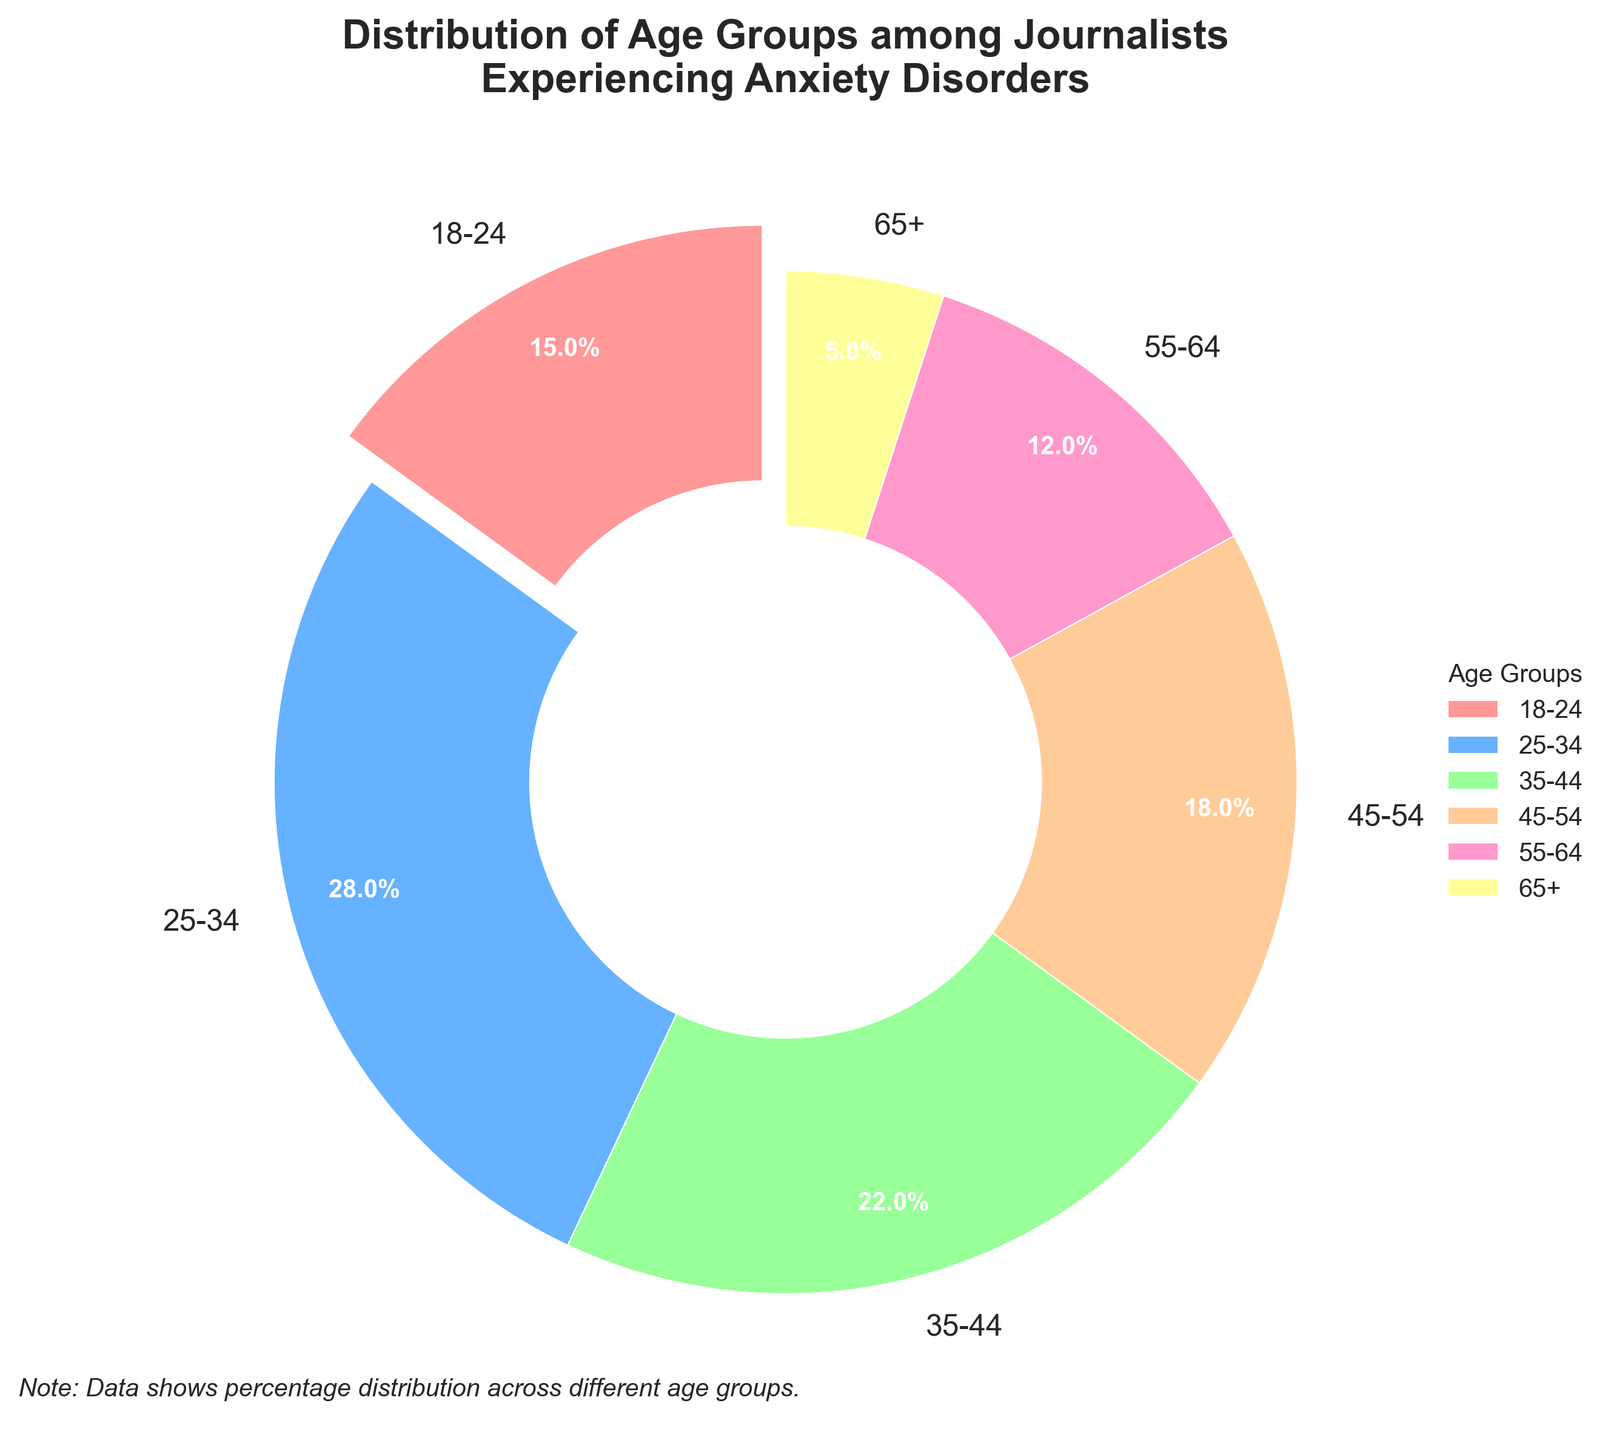Which age group has the highest percentage of journalists experiencing anxiety disorders? The figure shows a pie chart where each segment represents a different age group and their corresponding percentage. The age group with the highest percentage is clearly labeled.
Answer: 25-34 Which age group has the lowest percentage of journalists experiencing anxiety disorders? By observing the pie chart, we can identify the smallest segment, which represents the age group with the lowest percentage. This group is labeled on the chart.
Answer: 65+ What is the combined percentage of journalists aged 18-24 and 35-44 experiencing anxiety disorders? To find the combined percentage, sum the percentages of the 18-24 and 35-44 age groups: 15% (18-24) + 22% (35-44).
Answer: 37% How many percentage points more of journalists aged 25-34 experience anxiety disorders compared to those aged 55-64? Subtract the percentage of the 55-64 age group (12%) from the percentage of the 25-34 age group (28%): 28% - 12%.
Answer: 16% What percentage of journalists experiencing anxiety disorders are 45 years and older? Sum the percentages of the age groups 45-54 (18%), 55-64 (12%), and 65+ (5%): 18% + 12% + 5%.
Answer: 35% How does the percentage of journalists aged 35-44 compare to those aged 45-54? Compare the percentages of the two age groups: 35-44 is 22%, and 45-54 is 18%. 22% is greater than 18%.
Answer: Greater What is the average percentage of journalists experiencing anxiety disorders across all age groups? Sum the percentages of all age groups and divide by the number of groups: (15% + 28% + 22% + 18% + 12% + 5%) / 6.
Answer: 16.7% Which color represents the age group 25-34 in the pie chart? Identify the segment color in the pie chart labeled as 25-34.
Answer: Light blue What is the percentage difference between the age group with the highest anxiety disorder rate and the age group with the lowest? Subtract the percentage of the 65+ age group (5%) from the 25-34 age group (28%): 28% - 5%.
Answer: 23% Is the percentage of journalists aged 18-24 experiencing anxiety disorders more or less than double that of journalists aged 55-64? Compare double the percentage of the 55-64 age group (12% * 2 = 24%) to the percentage of the 18-24 age group (15%). 15% is less than 24%.
Answer: Less 